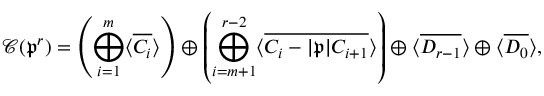Convert formula to latex. <formula><loc_0><loc_0><loc_500><loc_500>\mathcal { C } ( \mathfrak { p } ^ { r } ) = \left ( \bigoplus _ { i = 1 } ^ { m } \langle \overline { { C _ { i } } } \rangle \right ) \oplus \left ( \bigoplus _ { i = m + 1 } ^ { r - 2 } \langle \overline { { C _ { i } - | \mathfrak { p } | C _ { i + 1 } } } \rangle \right ) \oplus \langle \overline { { D _ { r - 1 } } } \rangle \oplus \langle \overline { { D _ { 0 } } } \rangle ,</formula> 